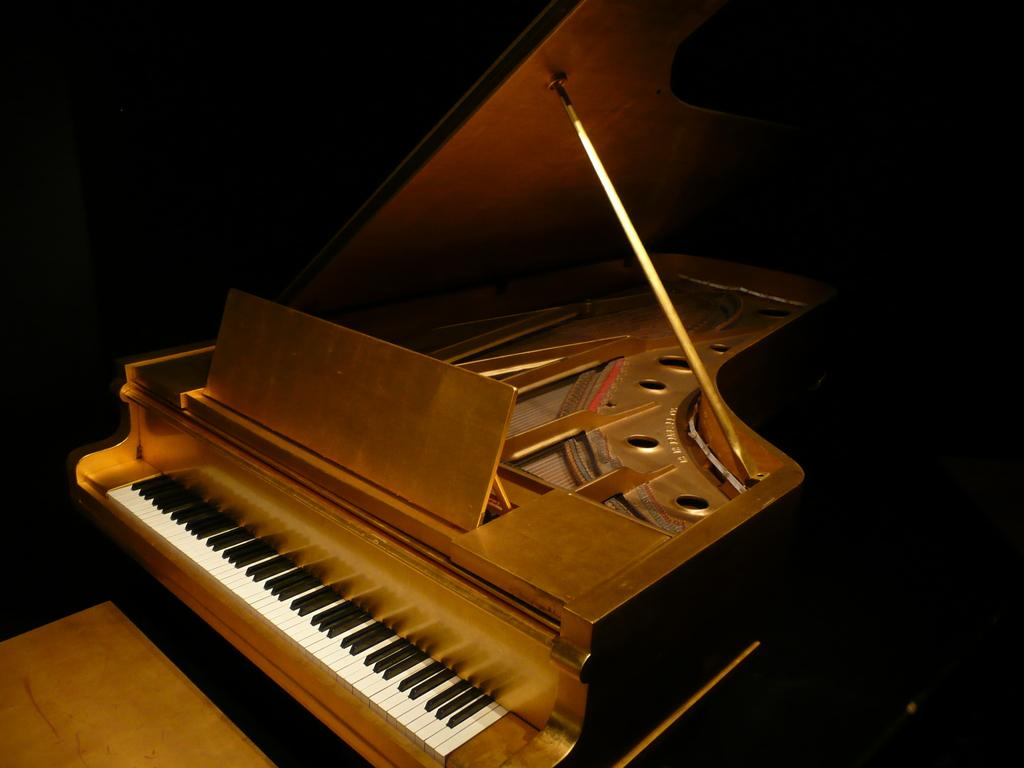What is the main object in the image? There is a piano in the image. What type of musical instrument is the piano? The piano is a keyboard instrument. What might someone be doing with the piano in the image? Someone might be playing the piano or practicing on it. Can you describe the size of the piano in the image? The size of the piano cannot be determined from the image alone. What type of brush is being used to paint the piano in the image? There is no brush or painting activity present in the image; it simply features a piano. 